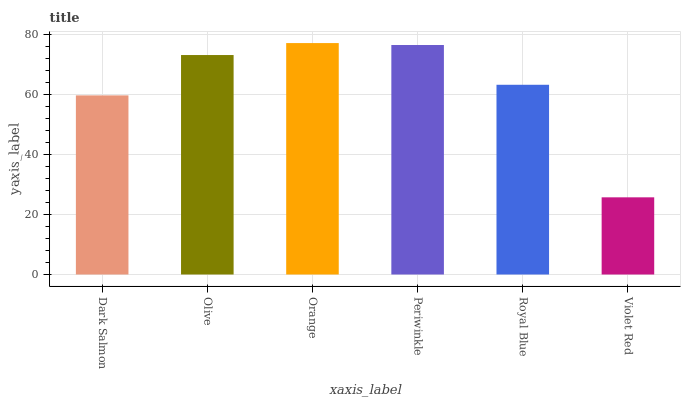Is Olive the minimum?
Answer yes or no. No. Is Olive the maximum?
Answer yes or no. No. Is Olive greater than Dark Salmon?
Answer yes or no. Yes. Is Dark Salmon less than Olive?
Answer yes or no. Yes. Is Dark Salmon greater than Olive?
Answer yes or no. No. Is Olive less than Dark Salmon?
Answer yes or no. No. Is Olive the high median?
Answer yes or no. Yes. Is Royal Blue the low median?
Answer yes or no. Yes. Is Orange the high median?
Answer yes or no. No. Is Periwinkle the low median?
Answer yes or no. No. 